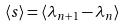Convert formula to latex. <formula><loc_0><loc_0><loc_500><loc_500>\langle s \rangle = \langle \lambda _ { n + 1 } - \lambda _ { n } \rangle</formula> 